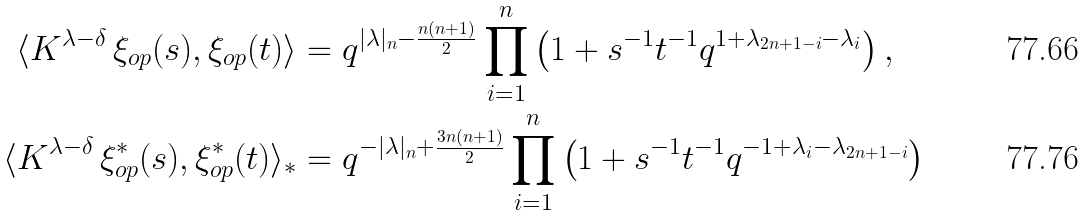Convert formula to latex. <formula><loc_0><loc_0><loc_500><loc_500>\langle K ^ { \lambda - \delta } \, \xi _ { o p } ( s ) , \xi _ { o p } ( t ) \rangle & = q ^ { | \lambda | _ { n } - \frac { n ( n + 1 ) } { 2 } } \prod _ { i = 1 } ^ { n } \left ( 1 + s ^ { - 1 } t ^ { - 1 } q ^ { 1 + \lambda _ { 2 n + 1 - i } - \lambda _ { i } } \right ) , \\ \langle K ^ { \lambda - \delta } \, \xi ^ { * } _ { o p } ( s ) , \xi ^ { * } _ { o p } ( t ) \rangle _ { * } & = q ^ { - | \lambda | _ { n } + \frac { 3 n ( n + 1 ) } { 2 } } \prod _ { i = 1 } ^ { n } \left ( 1 + s ^ { - 1 } t ^ { - 1 } q ^ { - 1 + \lambda _ { i } - \lambda _ { 2 n + 1 - i } } \right )</formula> 